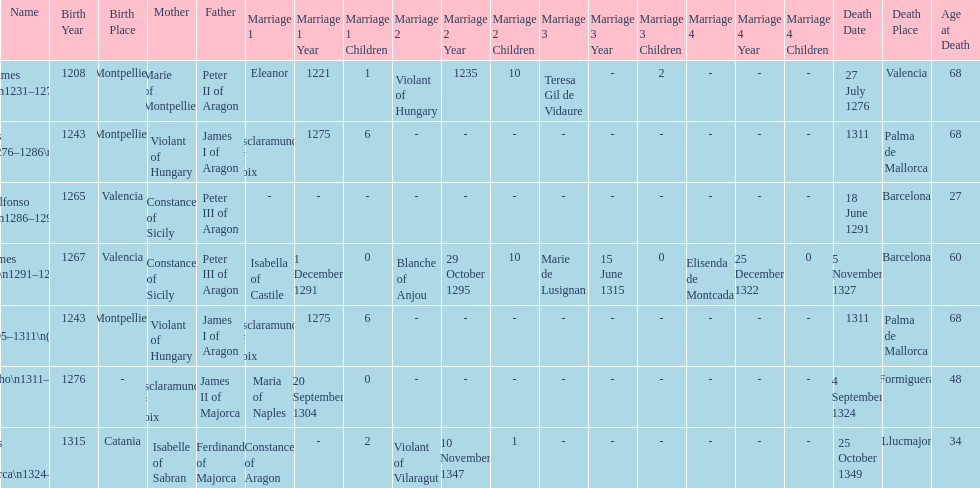Who came to power after the rule of james iii? James II. 